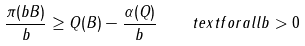<formula> <loc_0><loc_0><loc_500><loc_500>\frac { \pi ( b B ) } { b } \geq Q ( B ) - \frac { \alpha ( Q ) } { b } \quad t e x t { f o r a l l } b > 0</formula> 